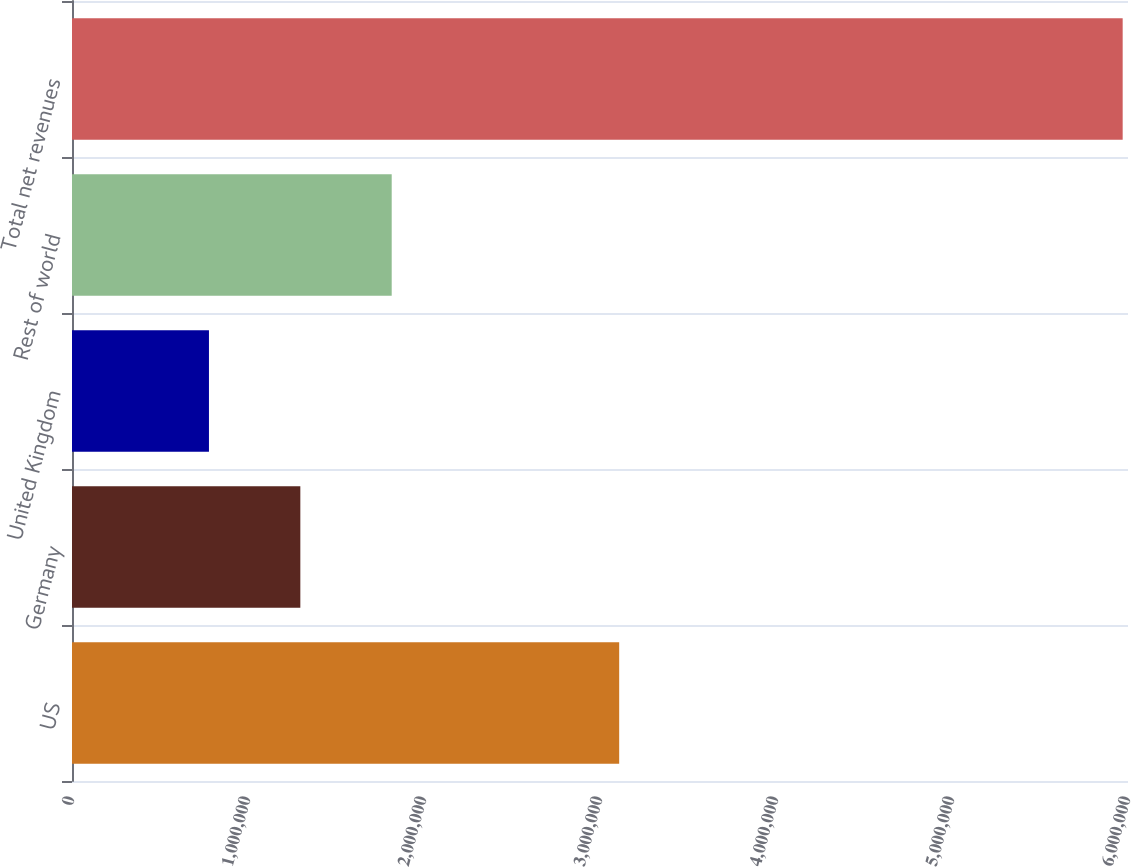Convert chart to OTSL. <chart><loc_0><loc_0><loc_500><loc_500><bar_chart><fcel>US<fcel>Germany<fcel>United Kingdom<fcel>Rest of world<fcel>Total net revenues<nl><fcel>3.10899e+06<fcel>1.29734e+06<fcel>778185<fcel>1.8165e+06<fcel>5.96974e+06<nl></chart> 